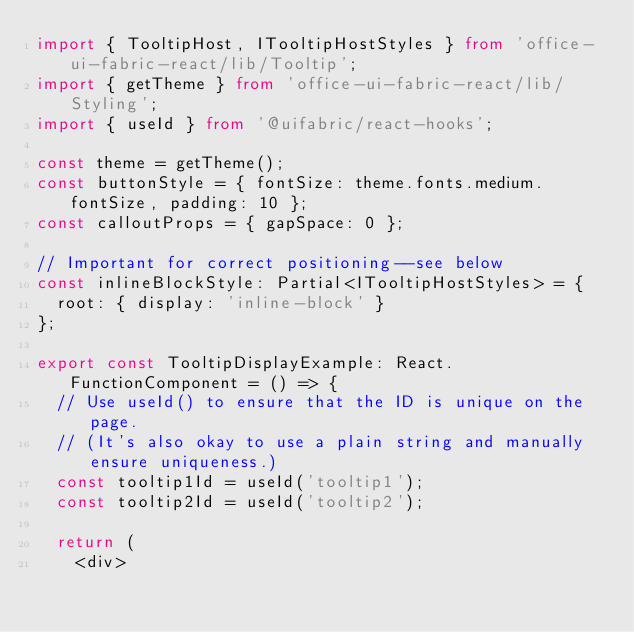<code> <loc_0><loc_0><loc_500><loc_500><_TypeScript_>import { TooltipHost, ITooltipHostStyles } from 'office-ui-fabric-react/lib/Tooltip';
import { getTheme } from 'office-ui-fabric-react/lib/Styling';
import { useId } from '@uifabric/react-hooks';

const theme = getTheme();
const buttonStyle = { fontSize: theme.fonts.medium.fontSize, padding: 10 };
const calloutProps = { gapSpace: 0 };

// Important for correct positioning--see below
const inlineBlockStyle: Partial<ITooltipHostStyles> = {
  root: { display: 'inline-block' }
};

export const TooltipDisplayExample: React.FunctionComponent = () => {
  // Use useId() to ensure that the ID is unique on the page.
  // (It's also okay to use a plain string and manually ensure uniqueness.)
  const tooltip1Id = useId('tooltip1');
  const tooltip2Id = useId('tooltip2');

  return (
    <div></code> 